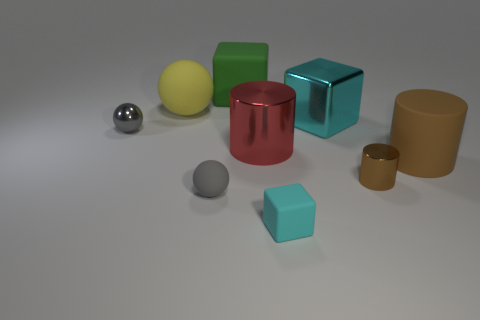Which of these objects appears to be the largest and what color is it? The largest object in the image seems to be the green cube, which has a smooth surface and a vibrant green hue. 